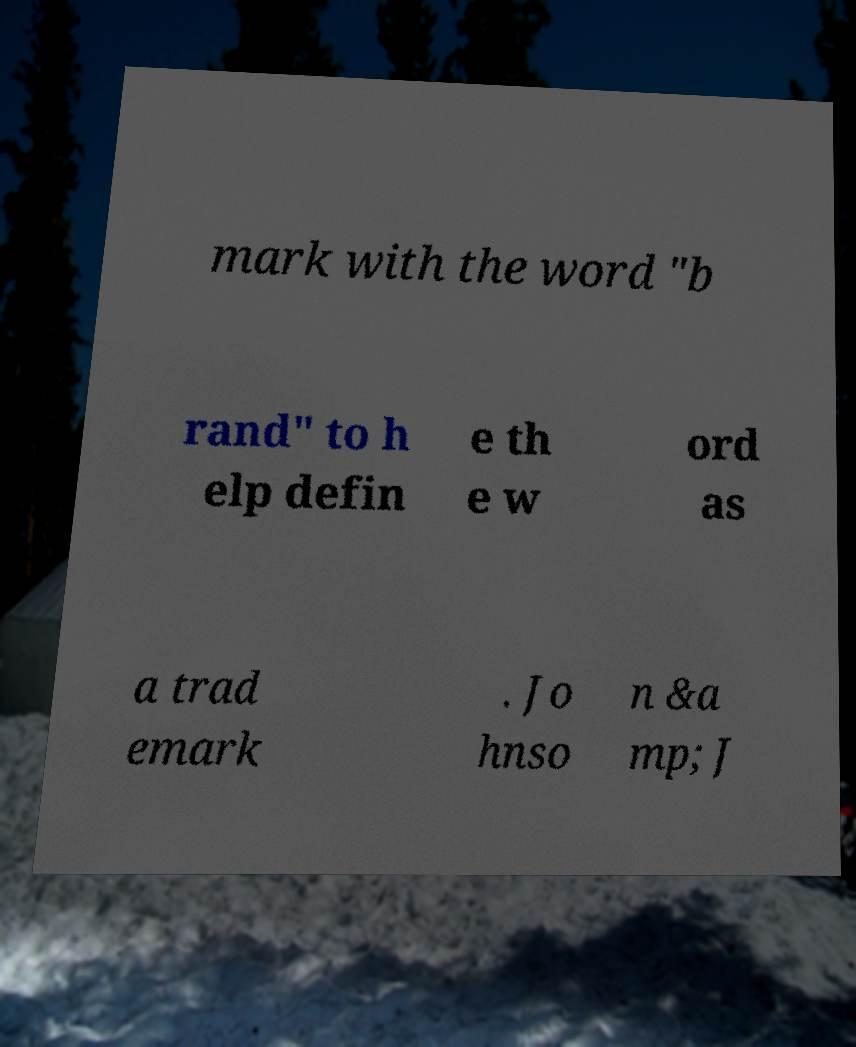There's text embedded in this image that I need extracted. Can you transcribe it verbatim? mark with the word "b rand" to h elp defin e th e w ord as a trad emark . Jo hnso n &a mp; J 